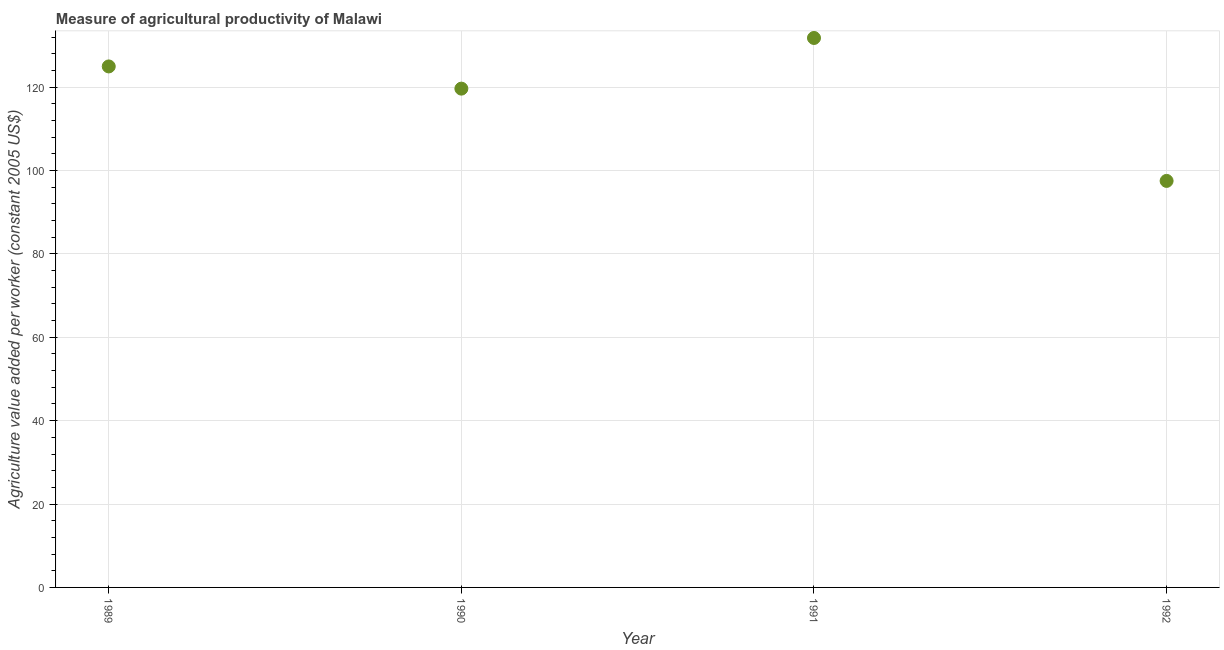What is the agriculture value added per worker in 1989?
Ensure brevity in your answer.  124.96. Across all years, what is the maximum agriculture value added per worker?
Your answer should be very brief. 131.78. Across all years, what is the minimum agriculture value added per worker?
Give a very brief answer. 97.5. In which year was the agriculture value added per worker maximum?
Give a very brief answer. 1991. In which year was the agriculture value added per worker minimum?
Offer a terse response. 1992. What is the sum of the agriculture value added per worker?
Your answer should be compact. 473.87. What is the difference between the agriculture value added per worker in 1989 and 1991?
Offer a very short reply. -6.82. What is the average agriculture value added per worker per year?
Offer a terse response. 118.47. What is the median agriculture value added per worker?
Keep it short and to the point. 122.3. Do a majority of the years between 1990 and 1991 (inclusive) have agriculture value added per worker greater than 44 US$?
Ensure brevity in your answer.  Yes. What is the ratio of the agriculture value added per worker in 1990 to that in 1991?
Offer a terse response. 0.91. Is the agriculture value added per worker in 1989 less than that in 1992?
Ensure brevity in your answer.  No. What is the difference between the highest and the second highest agriculture value added per worker?
Offer a terse response. 6.82. What is the difference between the highest and the lowest agriculture value added per worker?
Offer a very short reply. 34.28. In how many years, is the agriculture value added per worker greater than the average agriculture value added per worker taken over all years?
Provide a succinct answer. 3. Does the agriculture value added per worker monotonically increase over the years?
Offer a terse response. No. How many dotlines are there?
Your answer should be compact. 1. Does the graph contain any zero values?
Your response must be concise. No. Does the graph contain grids?
Give a very brief answer. Yes. What is the title of the graph?
Offer a very short reply. Measure of agricultural productivity of Malawi. What is the label or title of the Y-axis?
Provide a succinct answer. Agriculture value added per worker (constant 2005 US$). What is the Agriculture value added per worker (constant 2005 US$) in 1989?
Make the answer very short. 124.96. What is the Agriculture value added per worker (constant 2005 US$) in 1990?
Provide a short and direct response. 119.63. What is the Agriculture value added per worker (constant 2005 US$) in 1991?
Offer a very short reply. 131.78. What is the Agriculture value added per worker (constant 2005 US$) in 1992?
Your response must be concise. 97.5. What is the difference between the Agriculture value added per worker (constant 2005 US$) in 1989 and 1990?
Keep it short and to the point. 5.33. What is the difference between the Agriculture value added per worker (constant 2005 US$) in 1989 and 1991?
Keep it short and to the point. -6.82. What is the difference between the Agriculture value added per worker (constant 2005 US$) in 1989 and 1992?
Your response must be concise. 27.46. What is the difference between the Agriculture value added per worker (constant 2005 US$) in 1990 and 1991?
Offer a terse response. -12.15. What is the difference between the Agriculture value added per worker (constant 2005 US$) in 1990 and 1992?
Ensure brevity in your answer.  22.13. What is the difference between the Agriculture value added per worker (constant 2005 US$) in 1991 and 1992?
Make the answer very short. 34.28. What is the ratio of the Agriculture value added per worker (constant 2005 US$) in 1989 to that in 1990?
Your answer should be very brief. 1.04. What is the ratio of the Agriculture value added per worker (constant 2005 US$) in 1989 to that in 1991?
Keep it short and to the point. 0.95. What is the ratio of the Agriculture value added per worker (constant 2005 US$) in 1989 to that in 1992?
Give a very brief answer. 1.28. What is the ratio of the Agriculture value added per worker (constant 2005 US$) in 1990 to that in 1991?
Provide a succinct answer. 0.91. What is the ratio of the Agriculture value added per worker (constant 2005 US$) in 1990 to that in 1992?
Provide a short and direct response. 1.23. What is the ratio of the Agriculture value added per worker (constant 2005 US$) in 1991 to that in 1992?
Give a very brief answer. 1.35. 